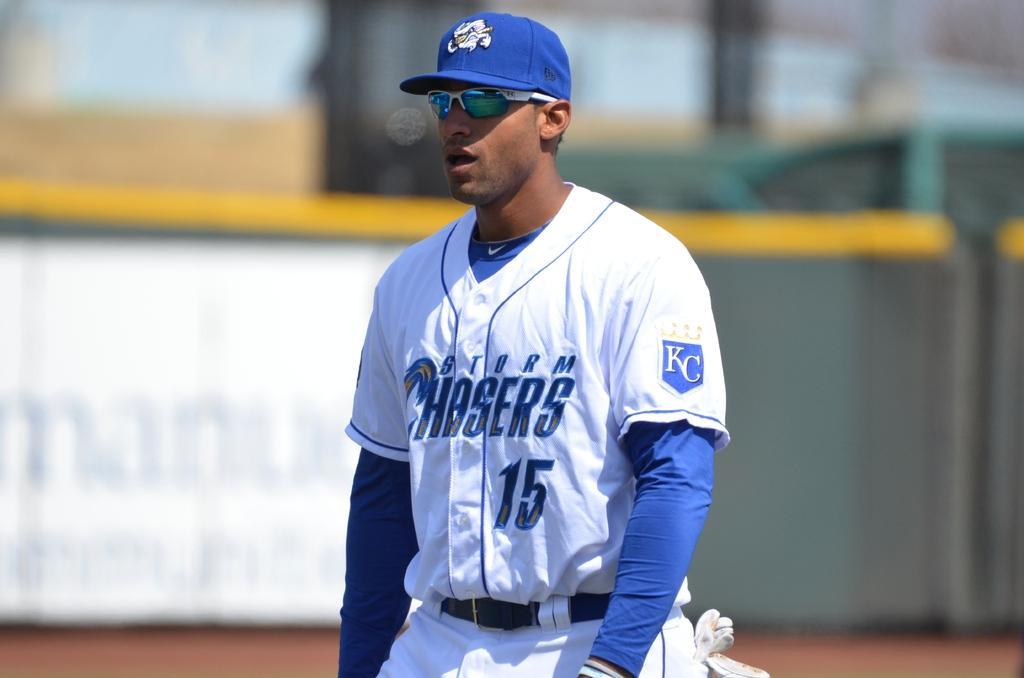<image>
Share a concise interpretation of the image provided. A man wearing a Chasers uniform is wearing glasses too. 